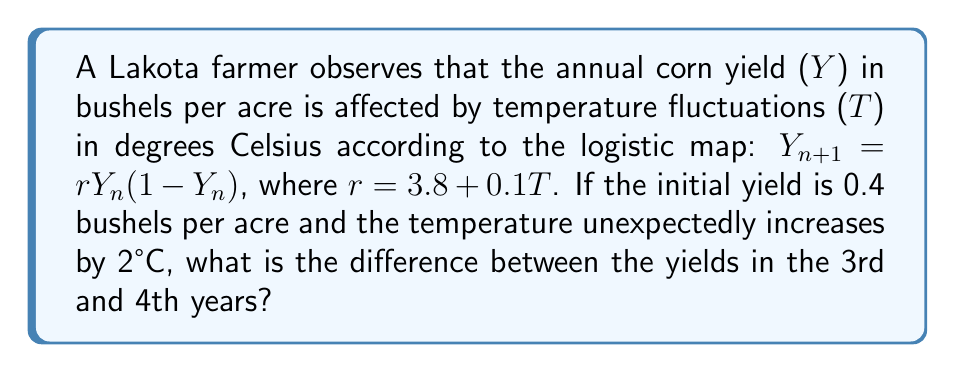Can you solve this math problem? Let's approach this step-by-step:

1) First, we need to calculate the r value:
   $r = 3.8 + 0.1T = 3.8 + 0.1(2) = 4$

2) Now, we'll use the logistic map equation to calculate the yields for each year:

   Year 1 (initial): $Y_0 = 0.4$

   Year 2: $Y_1 = 4(0.4)(1-0.4) = 0.96$

   Year 3: $Y_2 = 4(0.96)(1-0.96) = 0.1536$

   Year 4: $Y_3 = 4(0.1536)(1-0.1536) = 0.5202$

3) The question asks for the difference between the yields in the 3rd and 4th years:

   Difference = $Y_3 - Y_2 = 0.5202 - 0.1536 = 0.3666$

This demonstrates the chaotic nature of the system, as a small change in initial conditions (temperature increase) leads to significant and unpredictable changes in the outcome (crop yield).
Answer: 0.3666 bushels per acre 